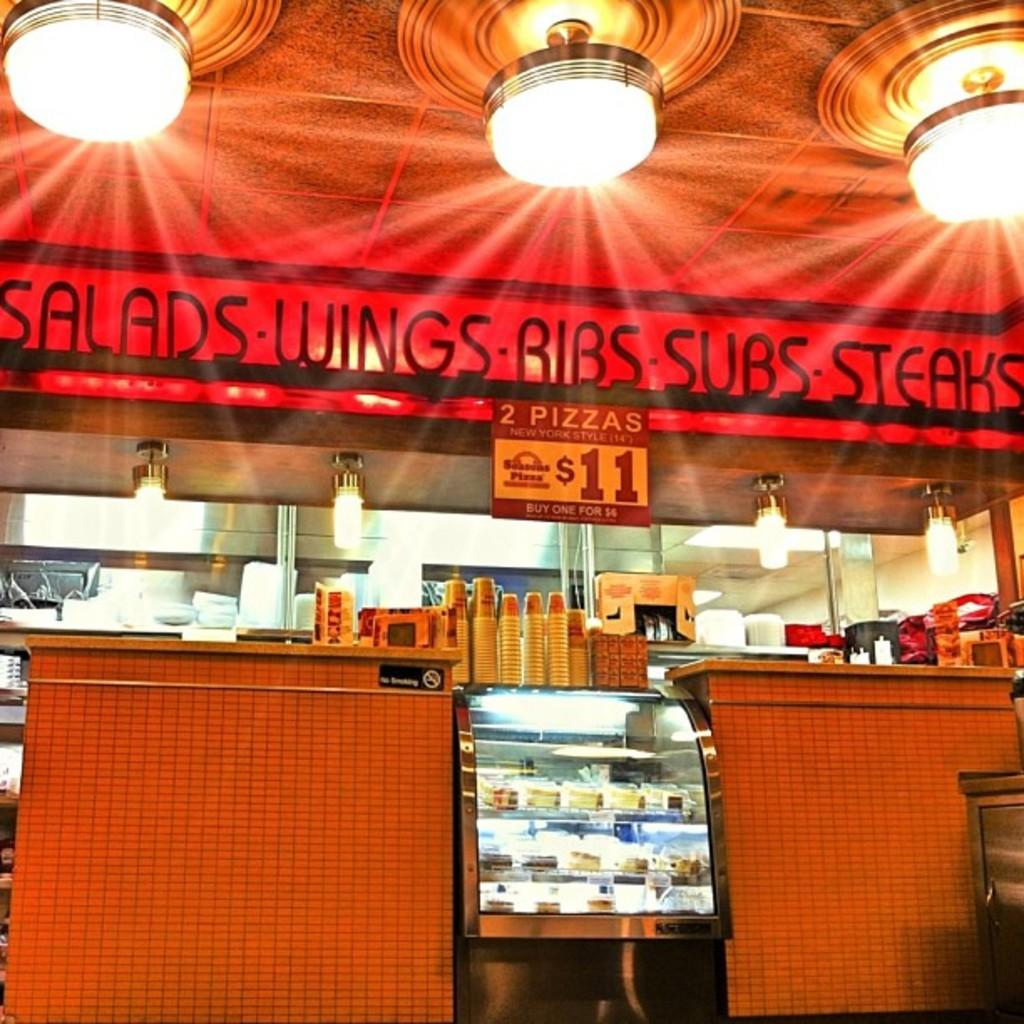Provide a one-sentence caption for the provided image. The restaurant sells salads, wings, ribs, subs, steaks and pizza. 